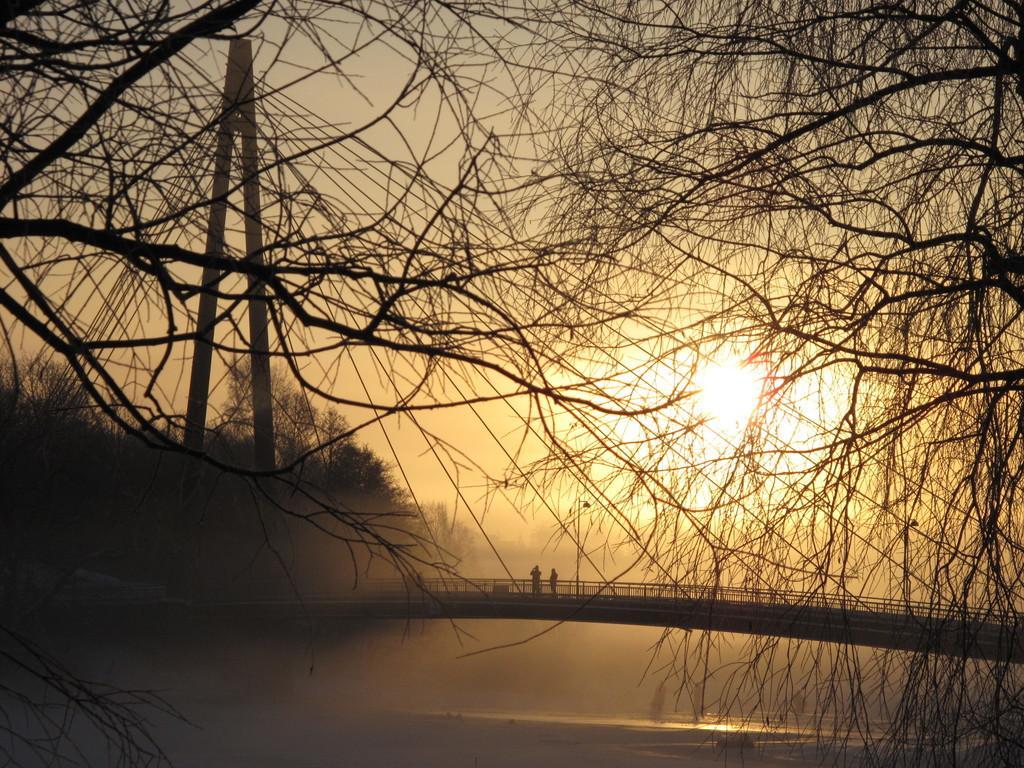Please provide a concise description of this image. In this image we can see a bridge and two persons standing on it. In the background we can see trees, lights, water and sun. 